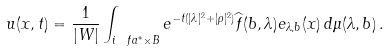<formula> <loc_0><loc_0><loc_500><loc_500>u ( x , t ) = \frac { 1 } { | W | } \int _ { i \ f a ^ { * } \times B } e ^ { - t ( | \lambda | ^ { 2 } + | \rho | ^ { 2 } ) } \widehat { f } ( b , \lambda ) e _ { \lambda , b } ( x ) \, d \mu ( \lambda , b ) \, .</formula> 